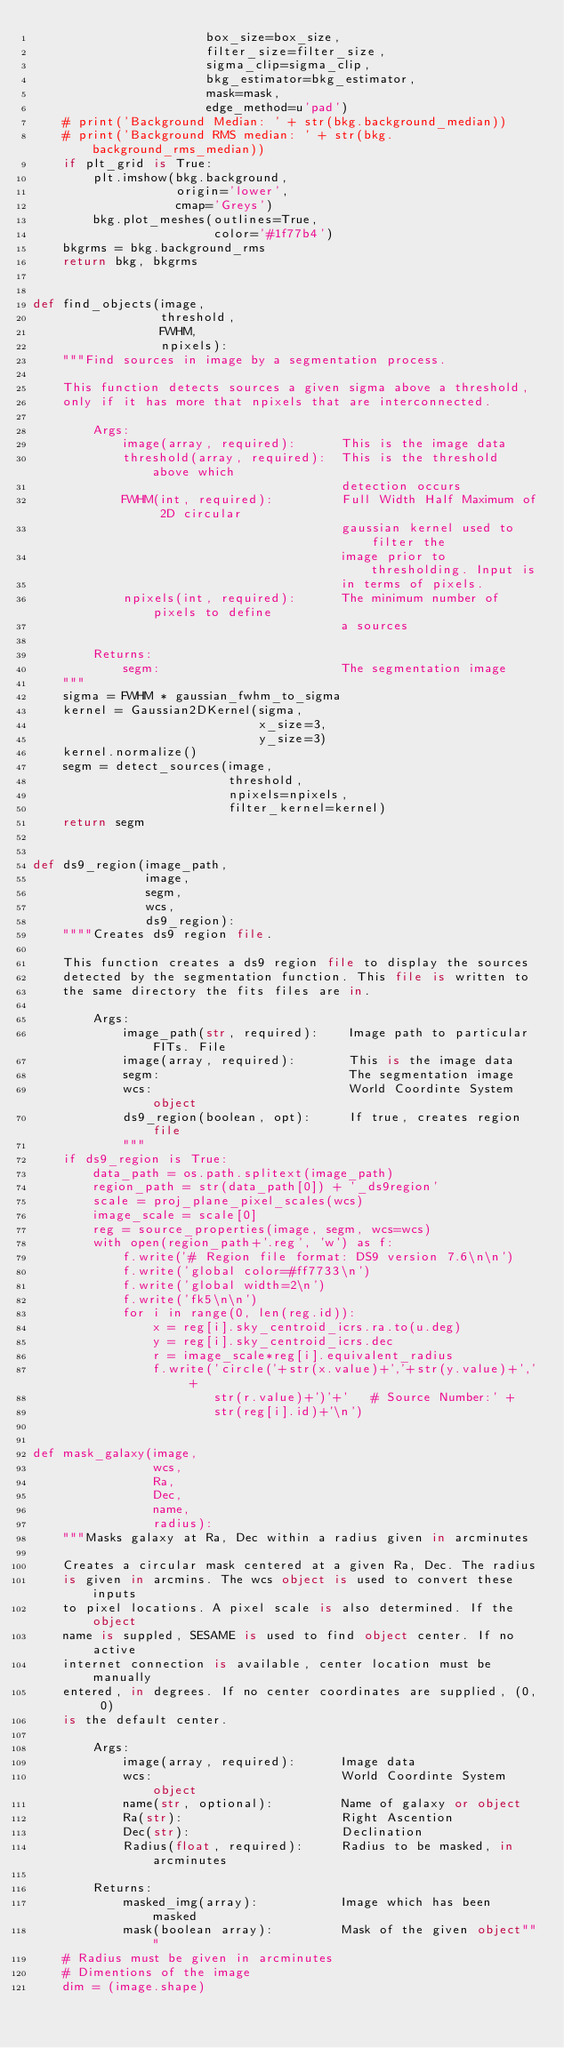<code> <loc_0><loc_0><loc_500><loc_500><_Python_>                       box_size=box_size,
                       filter_size=filter_size,
                       sigma_clip=sigma_clip,
                       bkg_estimator=bkg_estimator,
                       mask=mask,
                       edge_method=u'pad')
    # print('Background Median: ' + str(bkg.background_median))
    # print('Background RMS median: ' + str(bkg.background_rms_median))
    if plt_grid is True:
        plt.imshow(bkg.background,
                   origin='lower',
                   cmap='Greys')
        bkg.plot_meshes(outlines=True,
                        color='#1f77b4')
    bkgrms = bkg.background_rms
    return bkg, bkgrms


def find_objects(image,
                 threshold,
                 FWHM,
                 npixels):
    """Find sources in image by a segmentation process.

    This function detects sources a given sigma above a threshold,
    only if it has more that npixels that are interconnected.

        Args:
            image(array, required):      This is the image data
            threshold(array, required):  This is the threshold above which
                                         detection occurs
            FWHM(int, required):         Full Width Half Maximum of 2D circular
                                         gaussian kernel used to filter the
                                         image prior to thresholding. Input is
                                         in terms of pixels.
            npixels(int, required):      The minimum number of pixels to define
                                         a sources

        Returns:
            segm:                        The segmentation image
    """
    sigma = FWHM * gaussian_fwhm_to_sigma
    kernel = Gaussian2DKernel(sigma,
                              x_size=3,
                              y_size=3)
    kernel.normalize()
    segm = detect_sources(image,
                          threshold,
                          npixels=npixels,
                          filter_kernel=kernel)
    return segm


def ds9_region(image_path,
               image,
               segm,
               wcs,
               ds9_region):
    """"Creates ds9 region file.

    This function creates a ds9 region file to display the sources
    detected by the segmentation function. This file is written to
    the same directory the fits files are in.

        Args:
            image_path(str, required):    Image path to particular FITs. File
            image(array, required):       This is the image data
            segm:                         The segmentation image
            wcs:                          World Coordinte System object
            ds9_region(boolean, opt):     If true, creates region file
            """
    if ds9_region is True:
        data_path = os.path.splitext(image_path)
        region_path = str(data_path[0]) + '_ds9region'
        scale = proj_plane_pixel_scales(wcs)
        image_scale = scale[0]
        reg = source_properties(image, segm, wcs=wcs)
        with open(region_path+'.reg', 'w') as f:
            f.write('# Region file format: DS9 version 7.6\n\n')
            f.write('global color=#ff7733\n')
            f.write('global width=2\n')
            f.write('fk5\n\n')
            for i in range(0, len(reg.id)):
                x = reg[i].sky_centroid_icrs.ra.to(u.deg)
                y = reg[i].sky_centroid_icrs.dec
                r = image_scale*reg[i].equivalent_radius
                f.write('circle('+str(x.value)+','+str(y.value)+',' +
                        str(r.value)+')'+'   # Source Number:' +
                        str(reg[i].id)+'\n')


def mask_galaxy(image,
                wcs,
                Ra,
                Dec,
                name,
                radius):
    """Masks galaxy at Ra, Dec within a radius given in arcminutes

    Creates a circular mask centered at a given Ra, Dec. The radius
    is given in arcmins. The wcs object is used to convert these inputs
    to pixel locations. A pixel scale is also determined. If the object
    name is suppled, SESAME is used to find object center. If no active
    internet connection is available, center location must be manually
    entered, in degrees. If no center coordinates are supplied, (0, 0)
    is the default center.

        Args:
            image(array, required):      Image data
            wcs:                         World Coordinte System object
            name(str, optional):         Name of galaxy or object
            Ra(str):                     Right Ascention
            Dec(str):                    Declination
            Radius(float, required):     Radius to be masked, in arcminutes

        Returns:
            masked_img(array):           Image which has been masked
            mask(boolean array):         Mask of the given object"""
    # Radius must be given in arcminutes
    # Dimentions of the image
    dim = (image.shape)</code> 